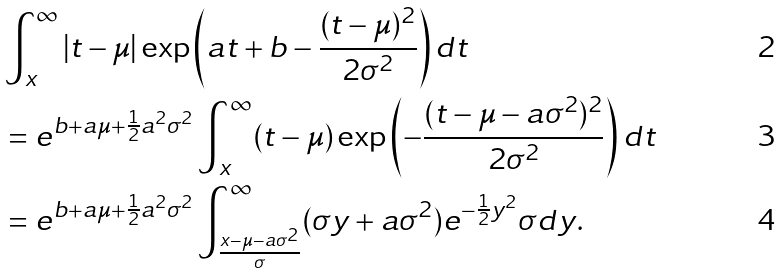<formula> <loc_0><loc_0><loc_500><loc_500>& \int _ { x } ^ { \infty } | t - \mu | \exp \left ( a t + b - \frac { ( t - \mu ) ^ { 2 } } { 2 \sigma ^ { 2 } } \right ) d t \\ & = e ^ { b + a \mu + \frac { 1 } { 2 } a ^ { 2 } \sigma ^ { 2 } } \int _ { x } ^ { \infty } ( t - \mu ) \exp \left ( - \frac { ( t - \mu - a \sigma ^ { 2 } ) ^ { 2 } } { 2 \sigma ^ { 2 } } \right ) d t \\ & = e ^ { b + a \mu + \frac { 1 } { 2 } a ^ { 2 } \sigma ^ { 2 } } \int _ { \frac { x - \mu - a \sigma ^ { 2 } } { \sigma } } ^ { \infty } ( \sigma y + a \sigma ^ { 2 } ) e ^ { - \frac { 1 } { 2 } y ^ { 2 } } \sigma d y .</formula> 